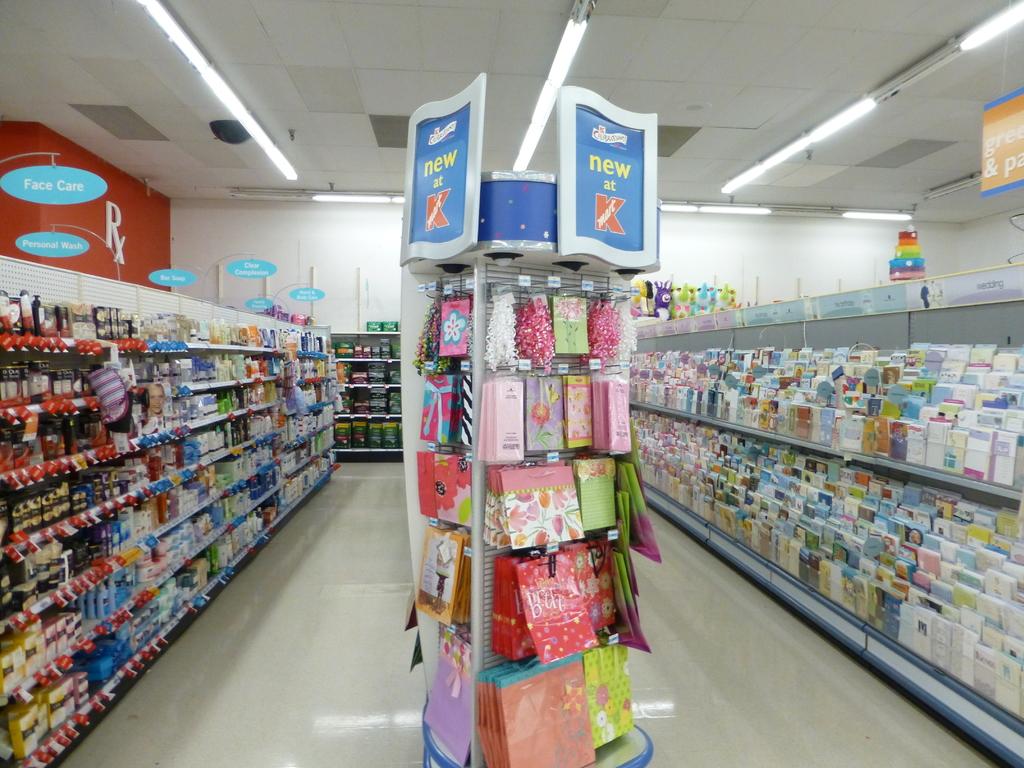What store is this?
Your answer should be compact. Kmart. What section is this?
Keep it short and to the point. Face care. 